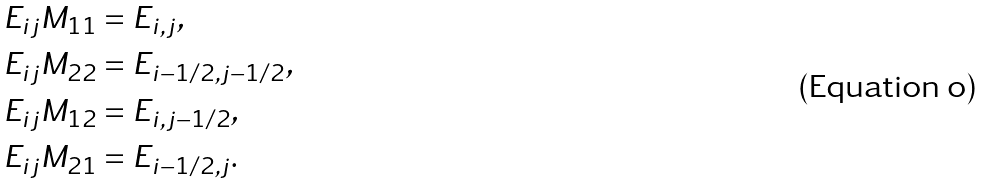Convert formula to latex. <formula><loc_0><loc_0><loc_500><loc_500>\, E _ { i j } M _ { 1 1 } & = E _ { i , j } , \\ \, E _ { i j } M _ { 2 2 } & = E _ { i - 1 / 2 , j - 1 / 2 } , \\ \, E _ { i j } M _ { 1 2 } & = E _ { i , j - 1 / 2 } , \\ \, E _ { i j } M _ { 2 1 } & = E _ { i - 1 / 2 , j } .</formula> 